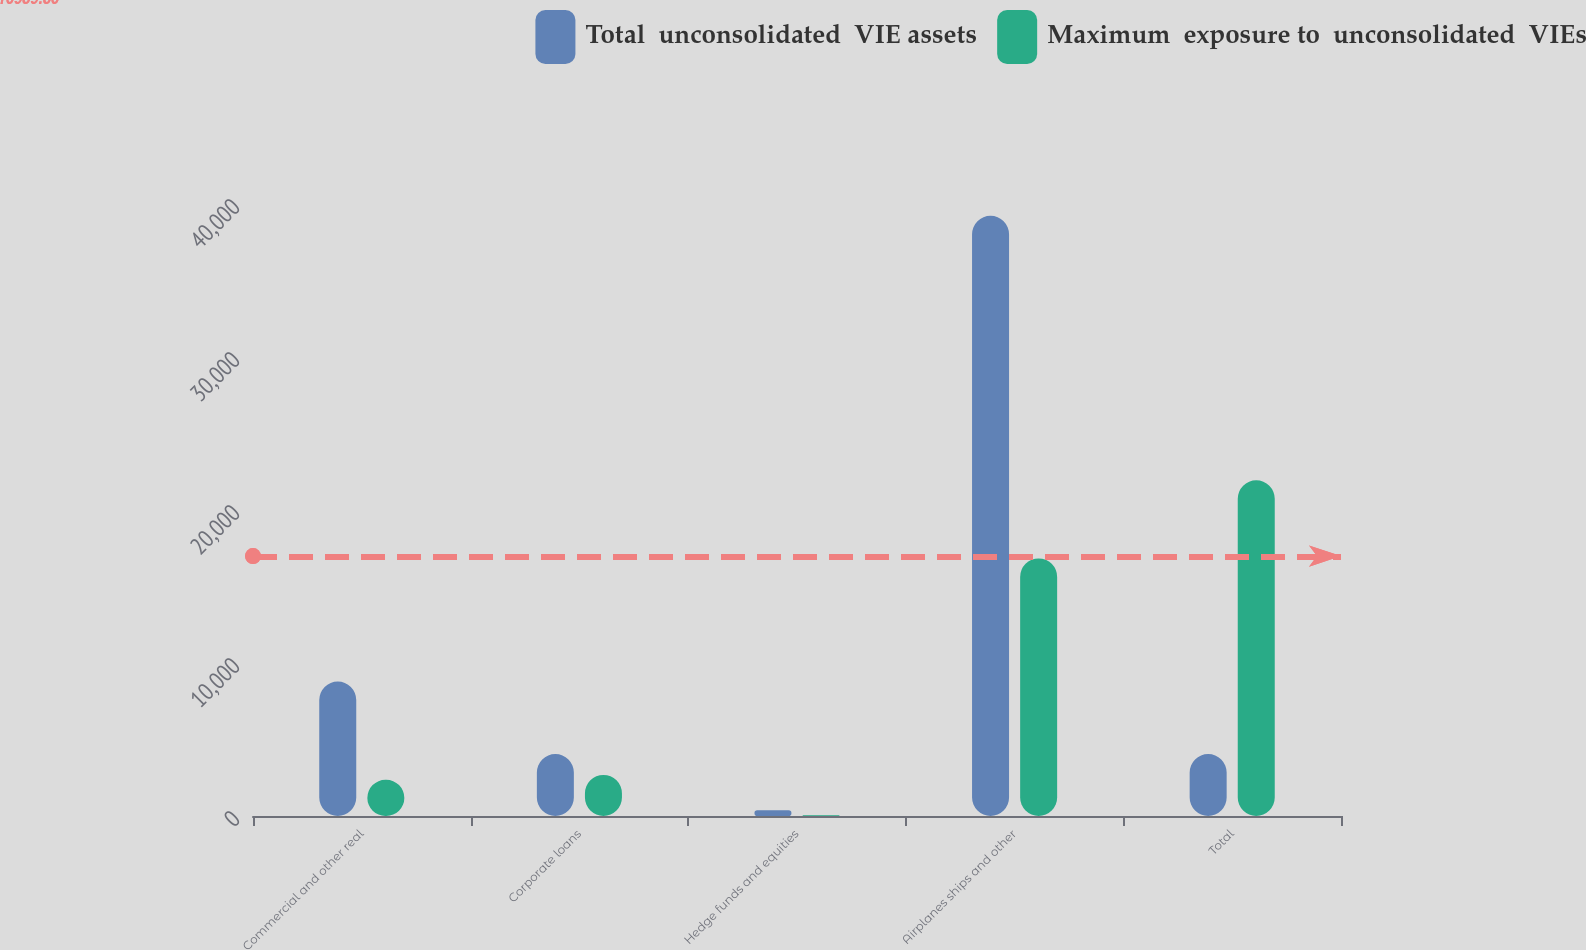Convert chart to OTSL. <chart><loc_0><loc_0><loc_500><loc_500><stacked_bar_chart><ecel><fcel>Commercial and other real<fcel>Corporate loans<fcel>Hedge funds and equities<fcel>Airplanes ships and other<fcel>Total<nl><fcel>Total  unconsolidated  VIE assets<fcel>8784<fcel>4051<fcel>370<fcel>39230<fcel>4051<nl><fcel>Maximum  exposure to  unconsolidated  VIEs<fcel>2368<fcel>2684<fcel>54<fcel>16837<fcel>21943<nl></chart> 